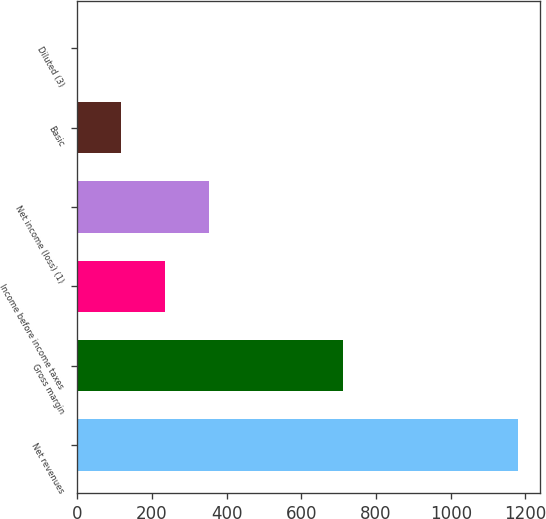Convert chart to OTSL. <chart><loc_0><loc_0><loc_500><loc_500><bar_chart><fcel>Net revenues<fcel>Gross margin<fcel>Income before income taxes<fcel>Net income (loss) (1)<fcel>Basic<fcel>Diluted (3)<nl><fcel>1179.8<fcel>711<fcel>236.48<fcel>354.4<fcel>118.56<fcel>0.64<nl></chart> 